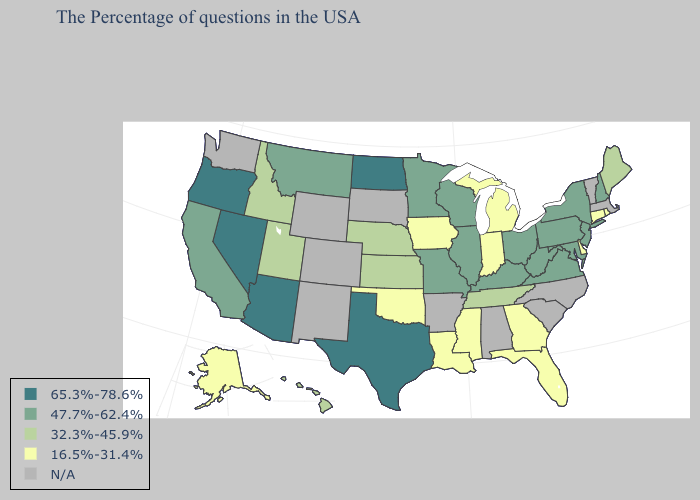What is the value of Colorado?
Concise answer only. N/A. Among the states that border Kansas , which have the lowest value?
Concise answer only. Oklahoma. Name the states that have a value in the range N/A?
Be succinct. Massachusetts, Vermont, North Carolina, South Carolina, Alabama, Arkansas, South Dakota, Wyoming, Colorado, New Mexico, Washington. Name the states that have a value in the range 16.5%-31.4%?
Quick response, please. Rhode Island, Connecticut, Delaware, Florida, Georgia, Michigan, Indiana, Mississippi, Louisiana, Iowa, Oklahoma, Alaska. Does New Jersey have the lowest value in the USA?
Answer briefly. No. How many symbols are there in the legend?
Quick response, please. 5. Name the states that have a value in the range N/A?
Answer briefly. Massachusetts, Vermont, North Carolina, South Carolina, Alabama, Arkansas, South Dakota, Wyoming, Colorado, New Mexico, Washington. Does Nevada have the lowest value in the West?
Give a very brief answer. No. Name the states that have a value in the range 16.5%-31.4%?
Write a very short answer. Rhode Island, Connecticut, Delaware, Florida, Georgia, Michigan, Indiana, Mississippi, Louisiana, Iowa, Oklahoma, Alaska. Name the states that have a value in the range 65.3%-78.6%?
Short answer required. Texas, North Dakota, Arizona, Nevada, Oregon. Which states have the lowest value in the West?
Short answer required. Alaska. Name the states that have a value in the range 65.3%-78.6%?
Quick response, please. Texas, North Dakota, Arizona, Nevada, Oregon. What is the highest value in the West ?
Keep it brief. 65.3%-78.6%. Among the states that border Minnesota , which have the highest value?
Answer briefly. North Dakota. Name the states that have a value in the range 47.7%-62.4%?
Quick response, please. New Hampshire, New York, New Jersey, Maryland, Pennsylvania, Virginia, West Virginia, Ohio, Kentucky, Wisconsin, Illinois, Missouri, Minnesota, Montana, California. 